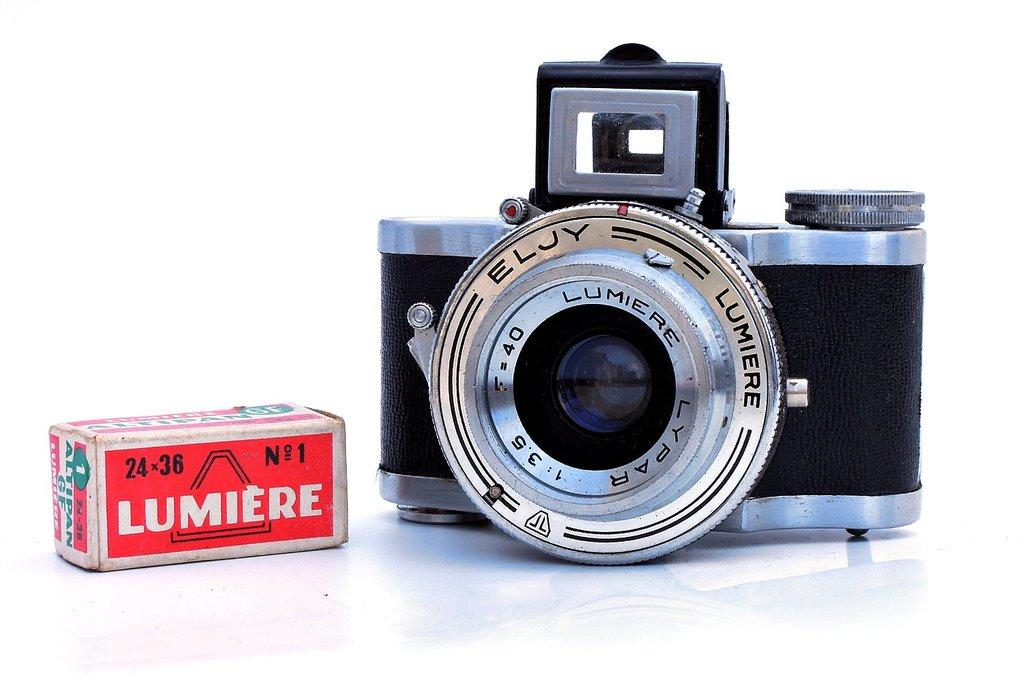What objects are on the floor in the image? There is a box and a camera on the floor in the image. What color is the background of the image? The background of the image is white. Can you describe the setting of the image? The image may have been taken in a house, as there is a box and a camera on the floor, which could suggest an indoor environment. How many stars can be seen falling in the image? There are no stars or falling stars visible in the image, as the background is white and the focus is on the box and camera on the floor. 